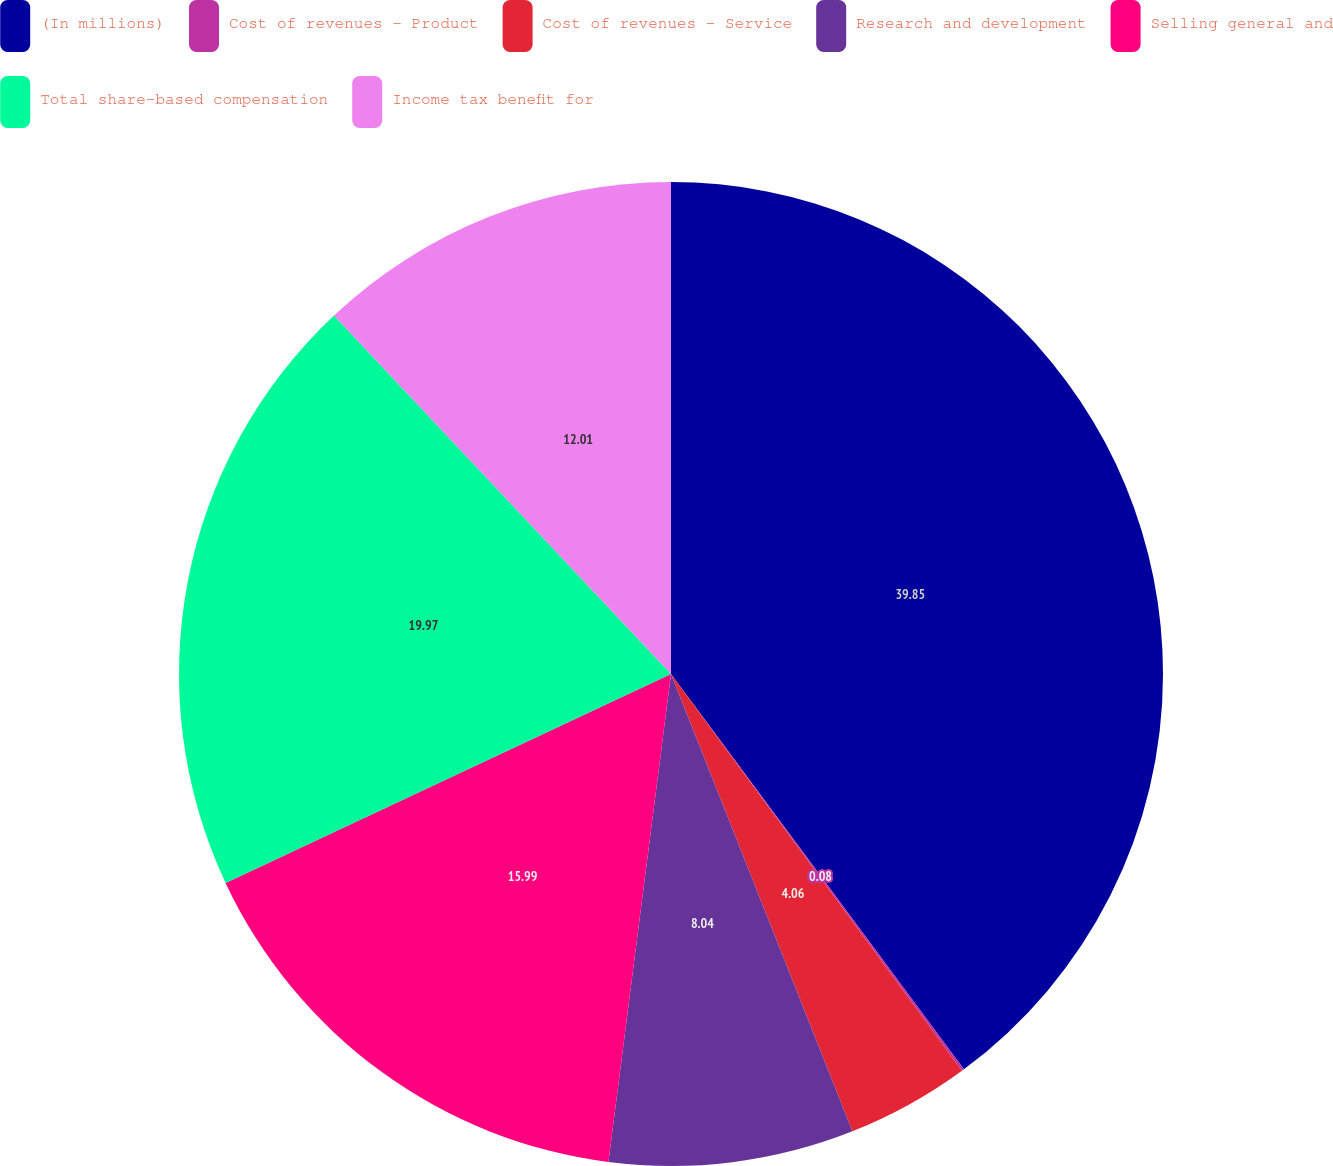Convert chart. <chart><loc_0><loc_0><loc_500><loc_500><pie_chart><fcel>(In millions)<fcel>Cost of revenues - Product<fcel>Cost of revenues - Service<fcel>Research and development<fcel>Selling general and<fcel>Total share-based compensation<fcel>Income tax benefit for<nl><fcel>39.85%<fcel>0.08%<fcel>4.06%<fcel>8.04%<fcel>15.99%<fcel>19.97%<fcel>12.01%<nl></chart> 